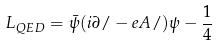Convert formula to latex. <formula><loc_0><loc_0><loc_500><loc_500>L _ { Q E D } = \bar { \psi } ( i \partial / - e A / ) \psi - \frac { 1 } { 4 }</formula> 